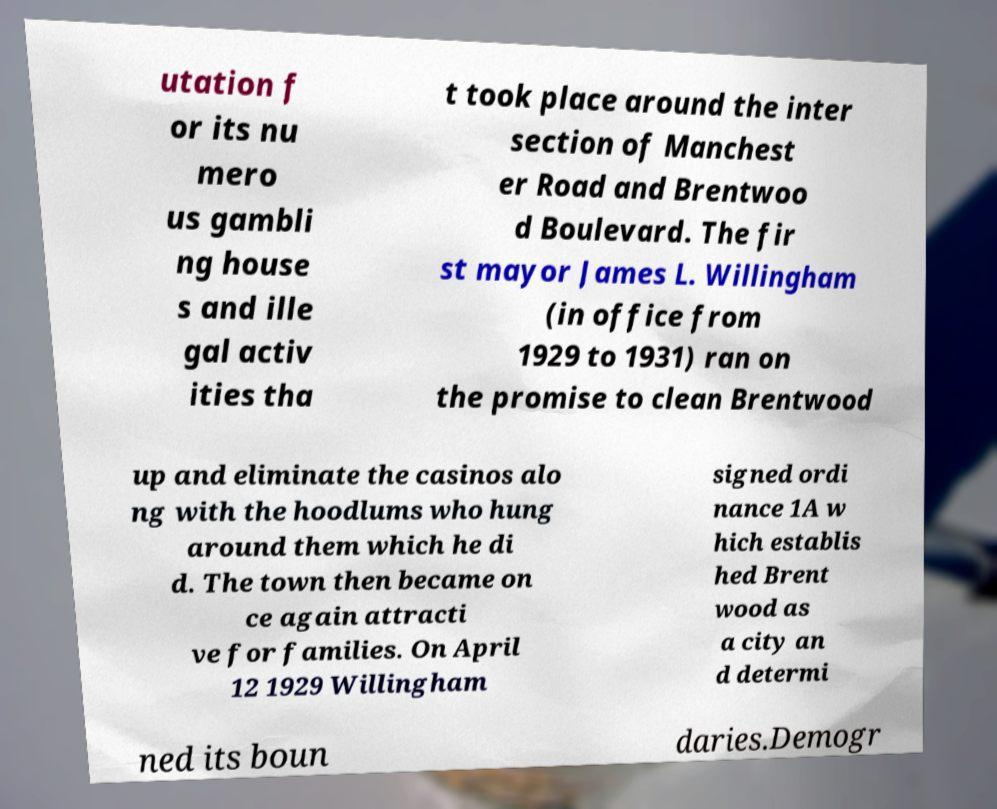Can you accurately transcribe the text from the provided image for me? utation f or its nu mero us gambli ng house s and ille gal activ ities tha t took place around the inter section of Manchest er Road and Brentwoo d Boulevard. The fir st mayor James L. Willingham (in office from 1929 to 1931) ran on the promise to clean Brentwood up and eliminate the casinos alo ng with the hoodlums who hung around them which he di d. The town then became on ce again attracti ve for families. On April 12 1929 Willingham signed ordi nance 1A w hich establis hed Brent wood as a city an d determi ned its boun daries.Demogr 